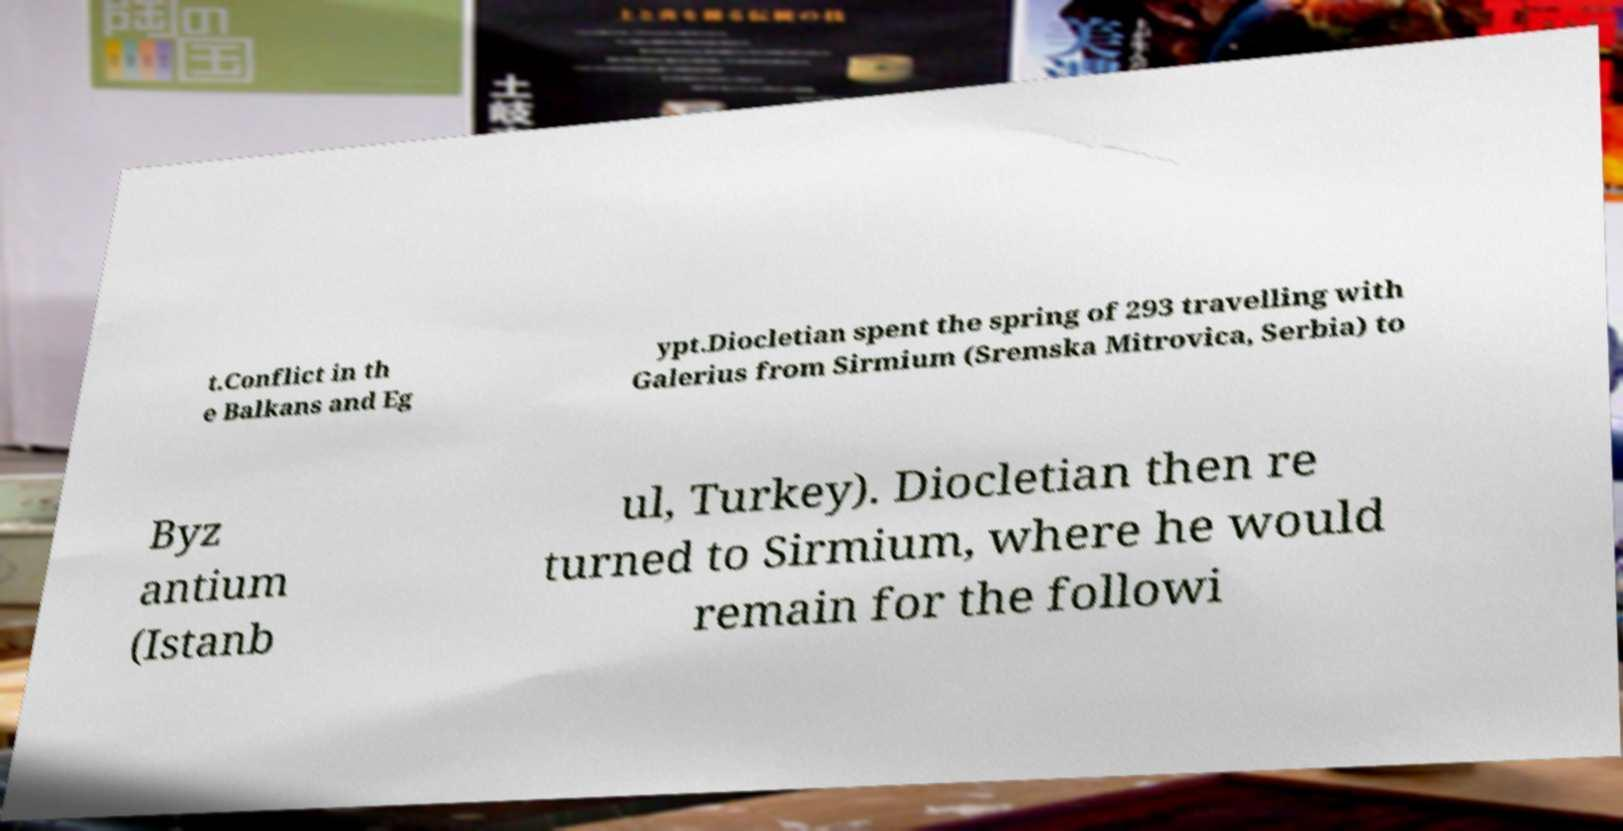I need the written content from this picture converted into text. Can you do that? t.Conflict in th e Balkans and Eg ypt.Diocletian spent the spring of 293 travelling with Galerius from Sirmium (Sremska Mitrovica, Serbia) to Byz antium (Istanb ul, Turkey). Diocletian then re turned to Sirmium, where he would remain for the followi 